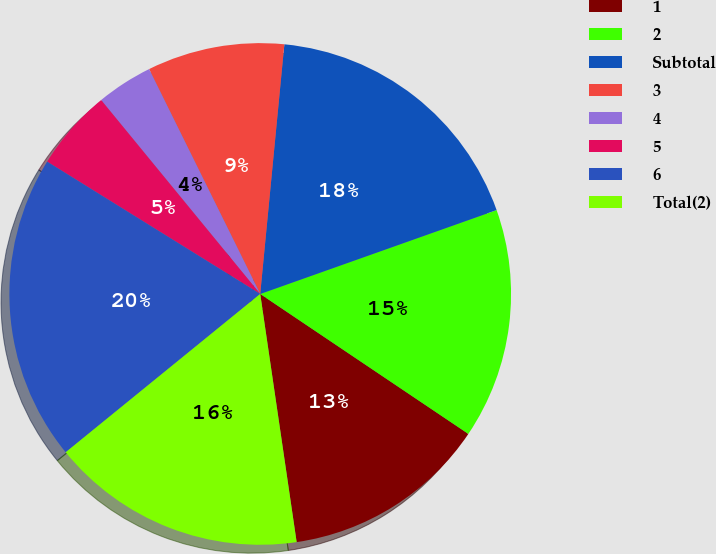Convert chart to OTSL. <chart><loc_0><loc_0><loc_500><loc_500><pie_chart><fcel>1<fcel>2<fcel>Subtotal<fcel>3<fcel>4<fcel>5<fcel>6<fcel>Total(2)<nl><fcel>13.26%<fcel>14.85%<fcel>18.04%<fcel>8.84%<fcel>3.63%<fcel>5.22%<fcel>19.72%<fcel>16.45%<nl></chart> 